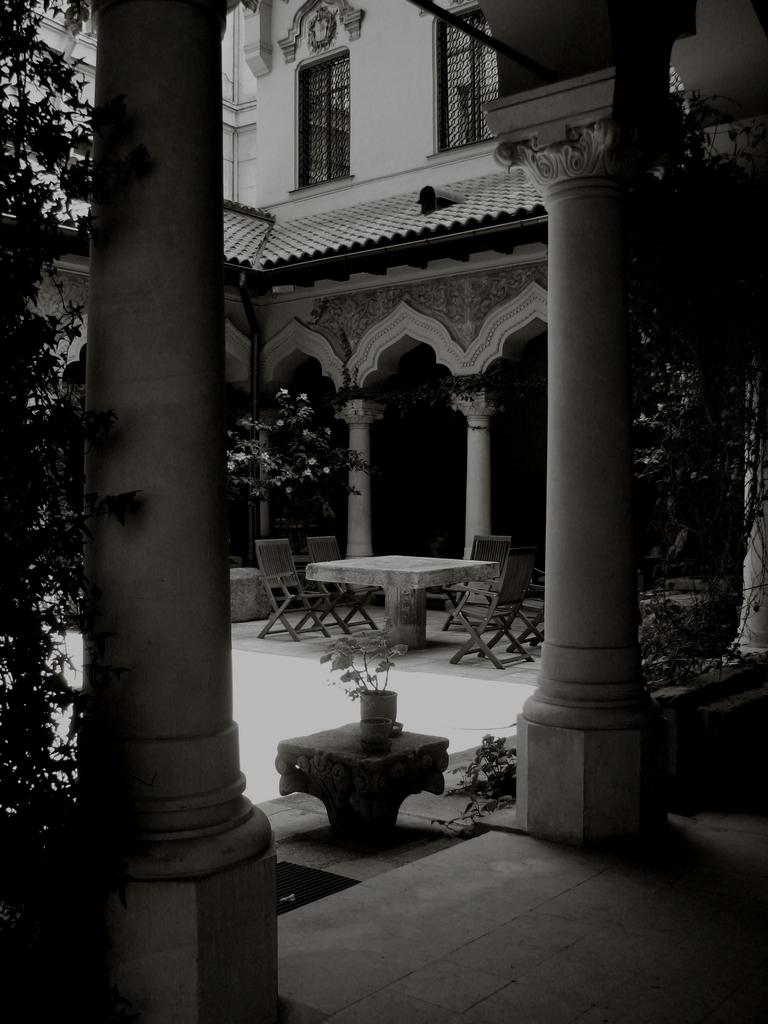What is the color scheme of the image? The image is black and white. What type of objects can be seen in the image? There are plants, pillars, windows, a floor, a wall, and chairs at a table in the image. Can you describe the architectural elements in the image? The image features pillars and windows. What type of setting is depicted in the image? The image shows a room with a floor, wall, and chairs at a table. How many beds are visible in the image? There are no beds present in the image. What type of basin is used for washing hands in the image? There is: There is no basin visible in the image. 